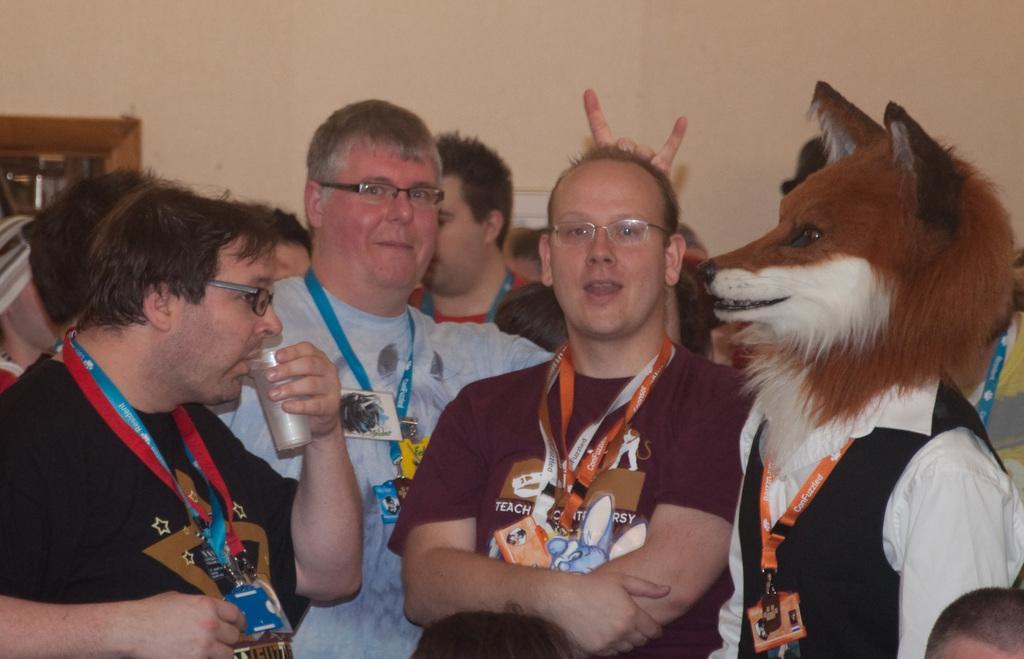In one or two sentences, can you explain what this image depicts? In this image there are a group of men standing towards the bottom of the image, they are wearing an identity cards, there is a man holding a glass and drinking, there is a man wearing a mask, at the background of the image there is a wall. 